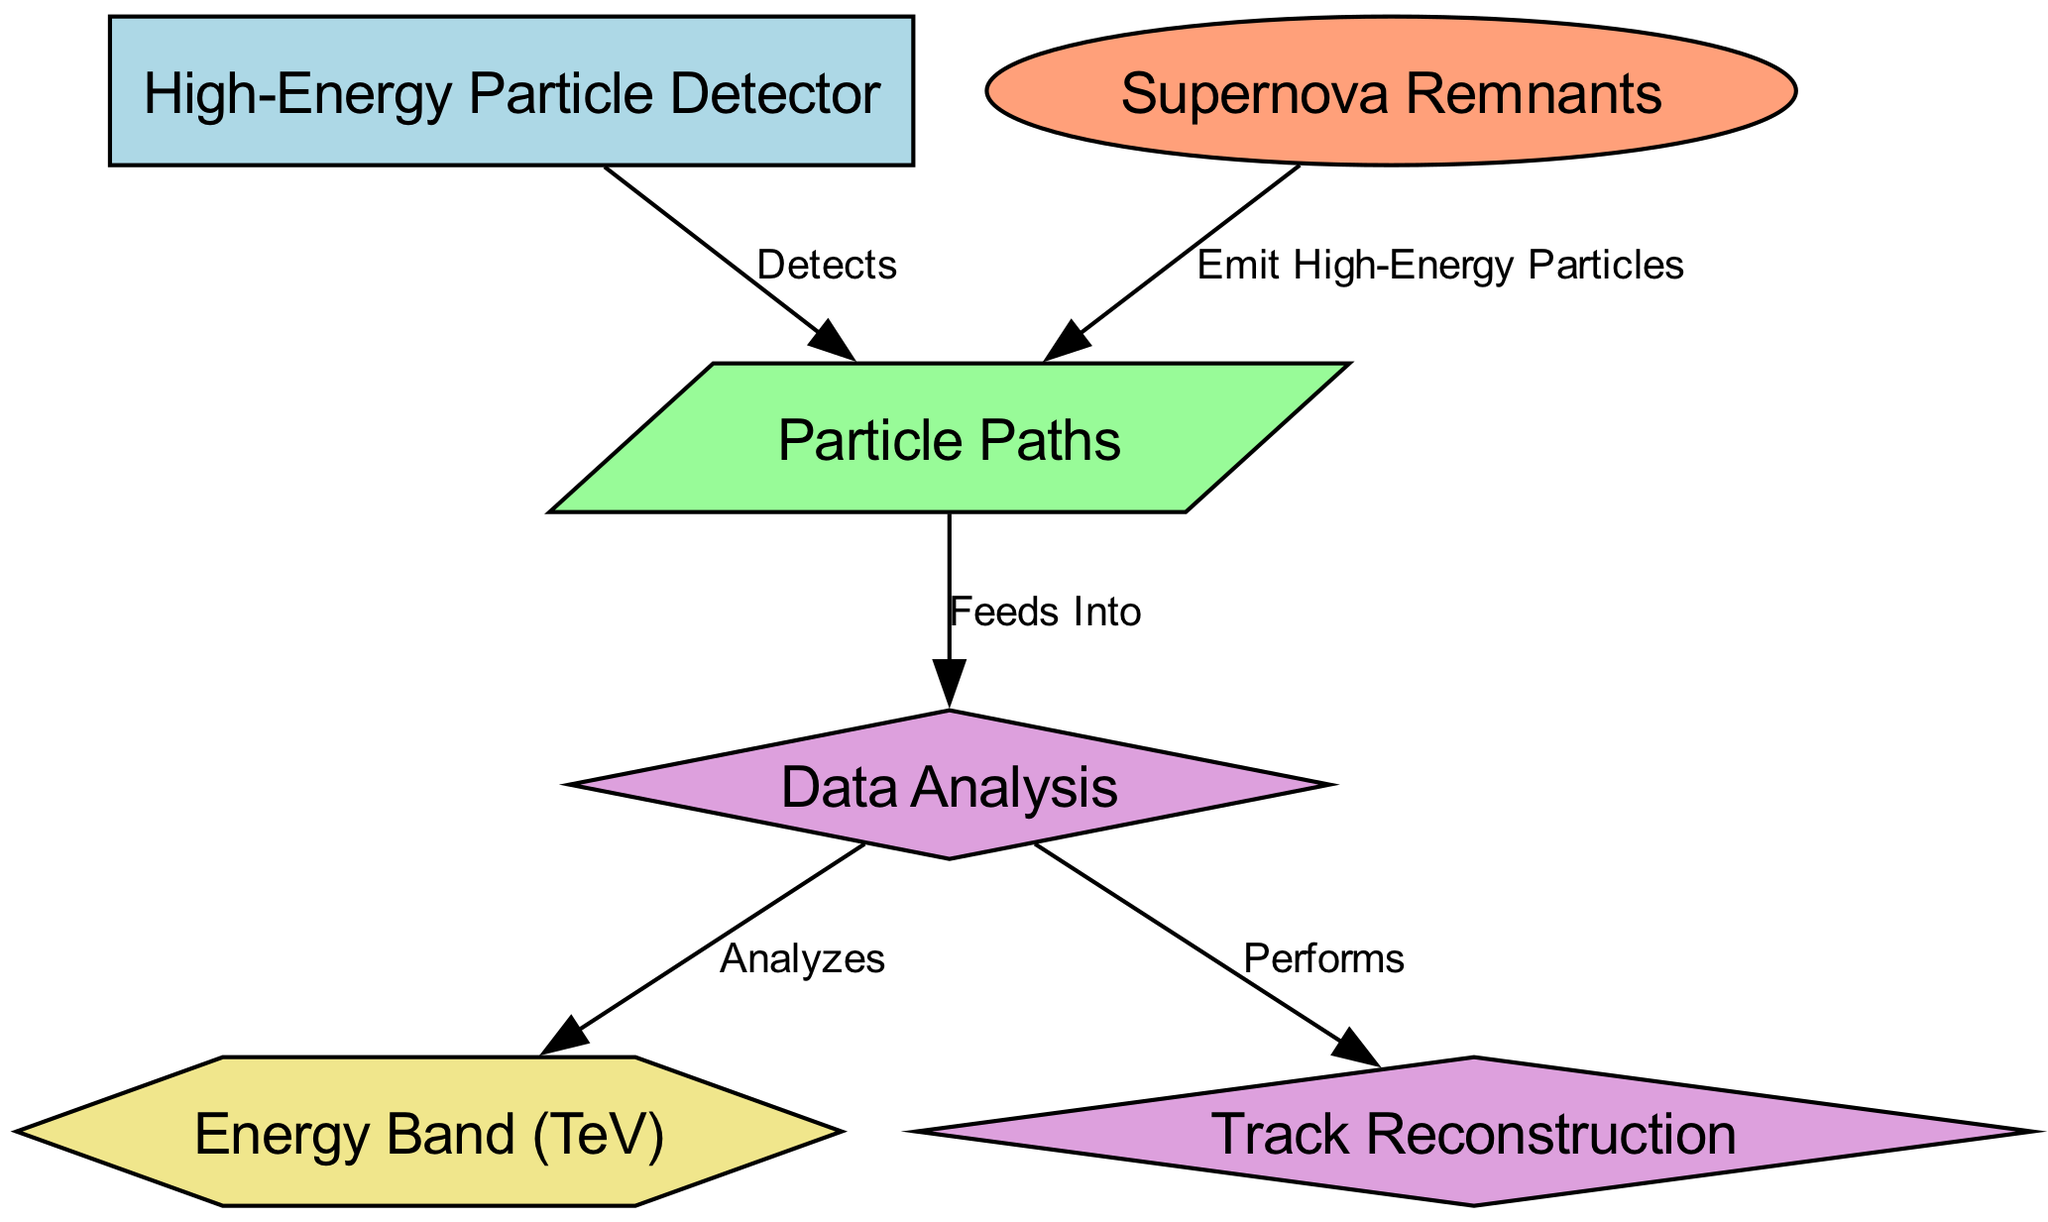What are the types of nodes present in the diagram? The diagram includes nodes of type 'equipment', 'astronomical_object', 'data', 'process', and 'attribute'. We can identify each type based on the defined types within the 'nodes' part of the data.
Answer: equipment, astronomical_object, data, process, attribute How many edges are there in the diagram? By examining the 'edges' section of the data, we can count that there are five edges that connect various nodes.
Answer: 5 What is the relationship between Supernova Remnants and Particle Paths? The relationship is indicated by the edge labeled "Emit High-Energy Particles" that connects the Supernova Remnants node to the Particle Paths node, showing that supernova remnants are the source of emitted particles.
Answer: Emit High-Energy Particles Which node performs track reconstruction? The node labeled 'Track Reconstruction' is connected to the 'Data Analysis' node. Since data analysis performs this process according to the edge labeled "Performs", this directly indicates where track reconstruction takes place.
Answer: Track Reconstruction What does the High-Energy Particle Detector do? According to the edge labeled "Detects," the High-Energy Particle Detector node is responsible for detecting the Particle Paths that are generated from the supernova remnants.
Answer: Detects Which type of node is the Energy Band? The Energy Band is categorized as an 'attribute', as indicated in the node type breakdown in the diagram, showing it serves to define a specific characteristic related to energy.
Answer: attribute In what unit is the Energy Band measured? The Energy Band is specified to be measured in TeV, a common unit used to quantify high-energy particles. This is indicated in the label of the Energy Band node itself.
Answer: TeV Which processes are directly linked to data analysis? Data Analysis is linked to two processes: it analyzes the energy band and performs track reconstruction. This is evident by the two edges going out from the data analysis node, labeled "Analyzes" and "Performs".
Answer: Analyzes, Performs 